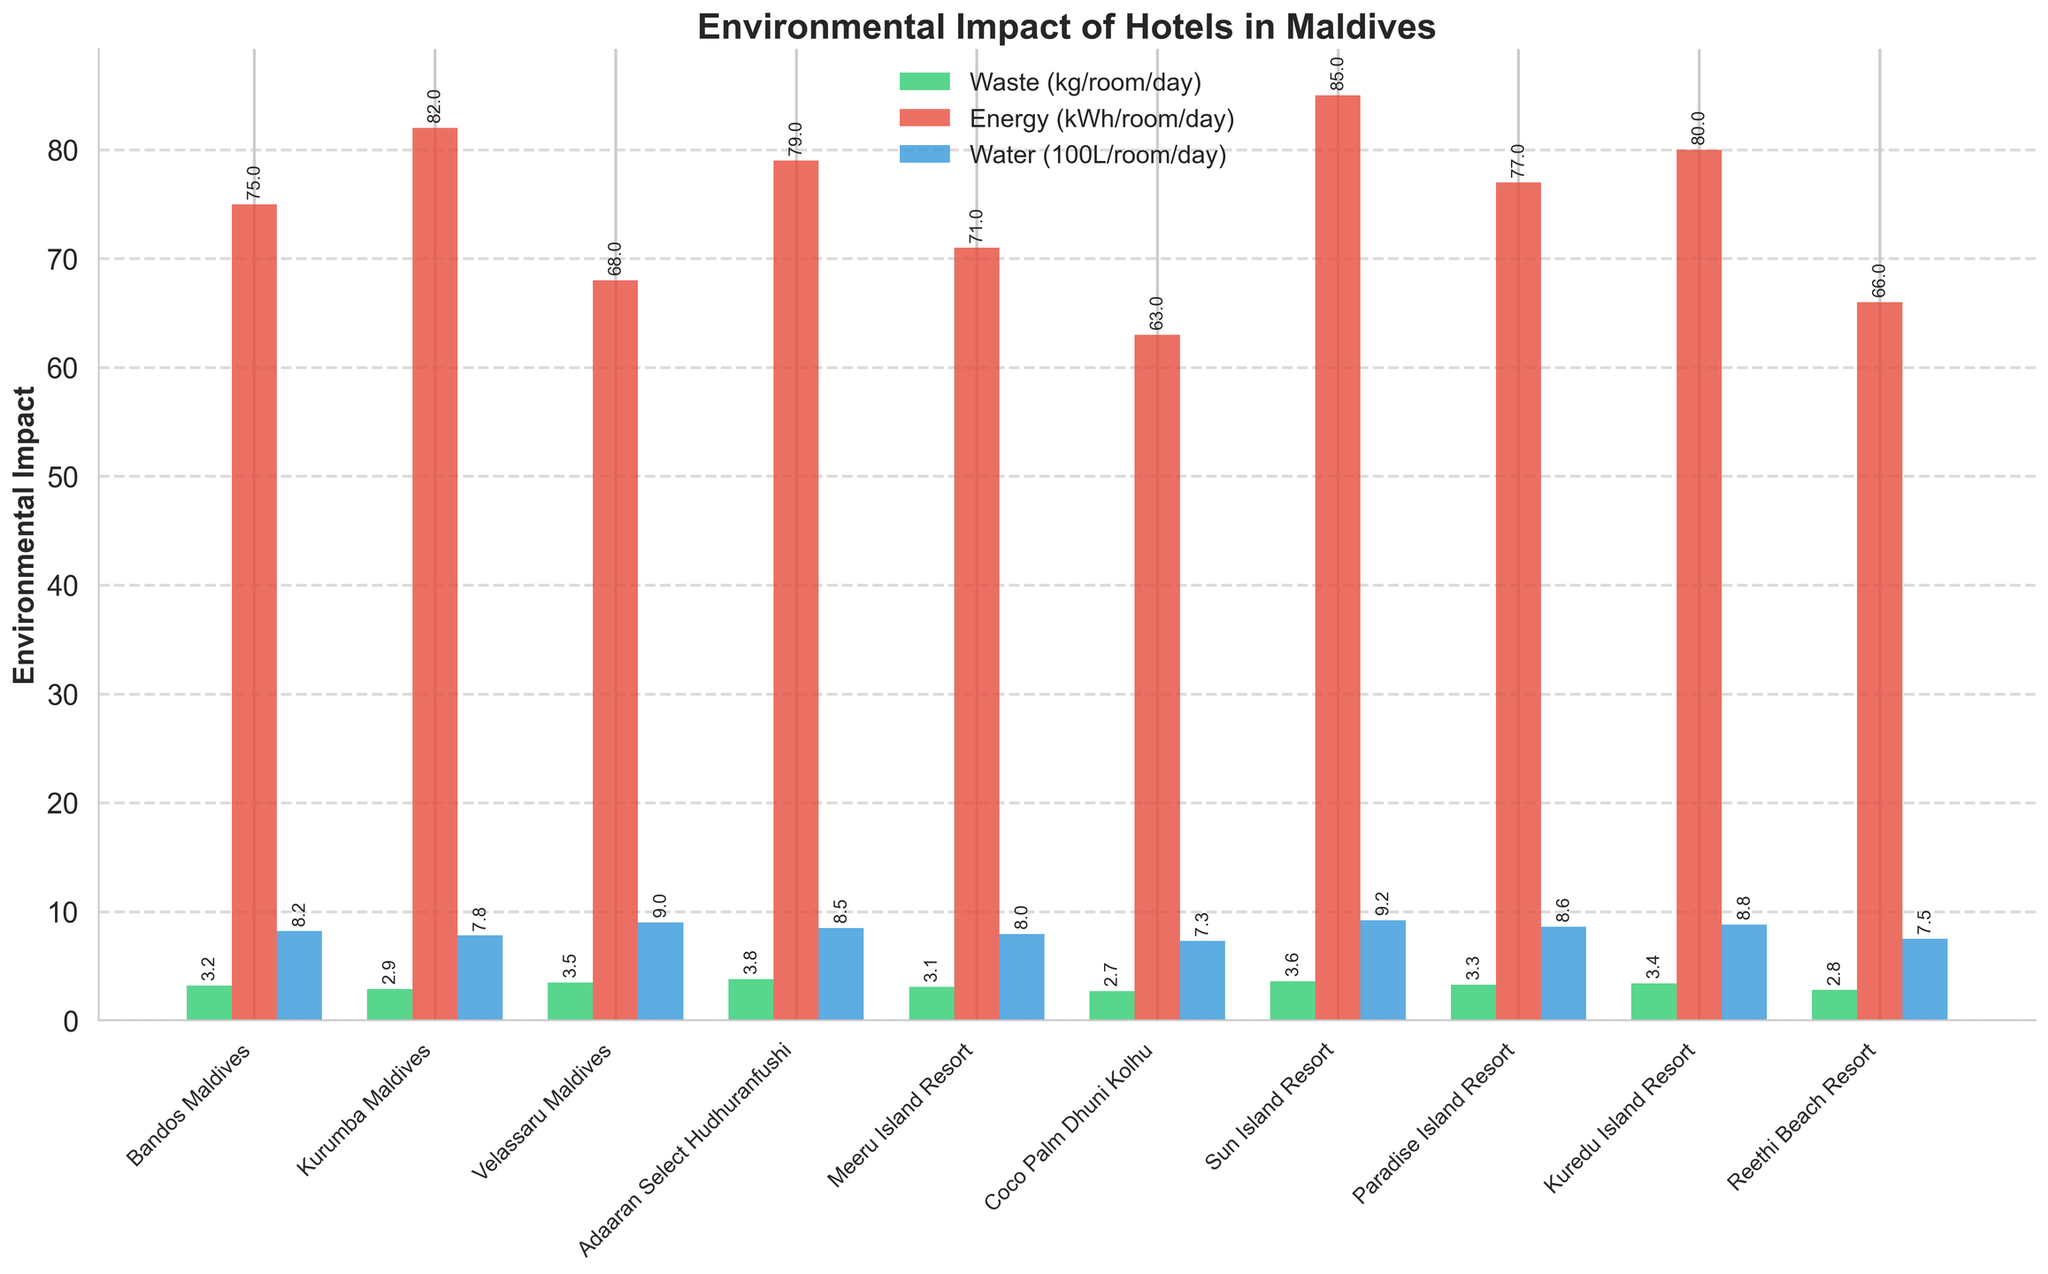Which hotel has the highest waste generation per room per day? By comparing the heights of the green bars in the figure, the highest waste generation can be identified. Adaaran Select Hudhuranfushi has the highest green bar.
Answer: Adaaran Select Hudhuranfushi Which hotel uses the most energy per room per day? By comparing the heights of the red bars in the figure, the highest energy consumption can be identified. Sun Island Resort has the highest red bar.
Answer: Sun Island Resort Which hotel uses the least water per room per day? By comparing the heights of the blue bars in the figure, the lowest water usage can be identified. Coco Palm Dhuni Kolhu has the shortest blue bar.
Answer: Coco Palm Dhuni Kolhu Which hotel has the highest combined environmental impact across all three categories? Look for the hotel with consistently high bars in green, red, and blue. Sun Island Resort has relatively high values in all three categories.
Answer: Sun Island Resort What is the difference in energy consumption between Kurumba Maldives and Coco Palm Dhuni Kolhu per room per day? The energy consumption for Kurumba Maldives is 82 kWh and for Coco Palm Dhuni Kolhu is 63 kWh. The difference is 82 - 63.
Answer: 19 kWh For which hotel is the water usage closest to 800 L per room per day? By visually inspecting the heights of the blue bars, Meeru Island Resort has a water usage closest to 800 L, at 795 L.
Answer: Meeru Island Resort Which hotel has the smallest difference between waste generation and energy consumption per room per day? Calculate the differences between waste and energy for each hotel and find the smallest one. For Reethi Beach Resort, the differences are 2.8 kg vs. 66 kWh, resulting in a minimal difference of 63.2.
Answer: Reethi Beach Resort What is the average water usage per room per day among all the hotels? Add all the water usage figures and divide by the number of hotels (10). The total is 820 + 780 + 900 + 850 + 795 + 730 + 920 + 860 + 880 + 750 = 8285 L. The average is 8285 / 10.
Answer: 828.5 L Which hotel uses less water but more energy compared to Kuredu Island Resort? Kuredu Island Resort uses 880 L water and 80 kWh energy. Only Paradise Island Resort uses 860 L water and 77 kWh energy, hence using less water but slightly more energy proportionately.
Answer: Paradise Island Resort 